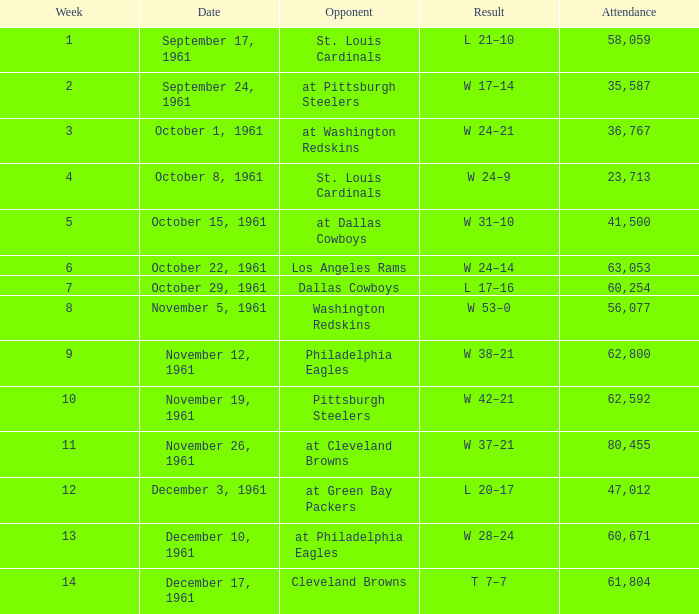Which presence has a date of november 19, 1961? 62592.0. 